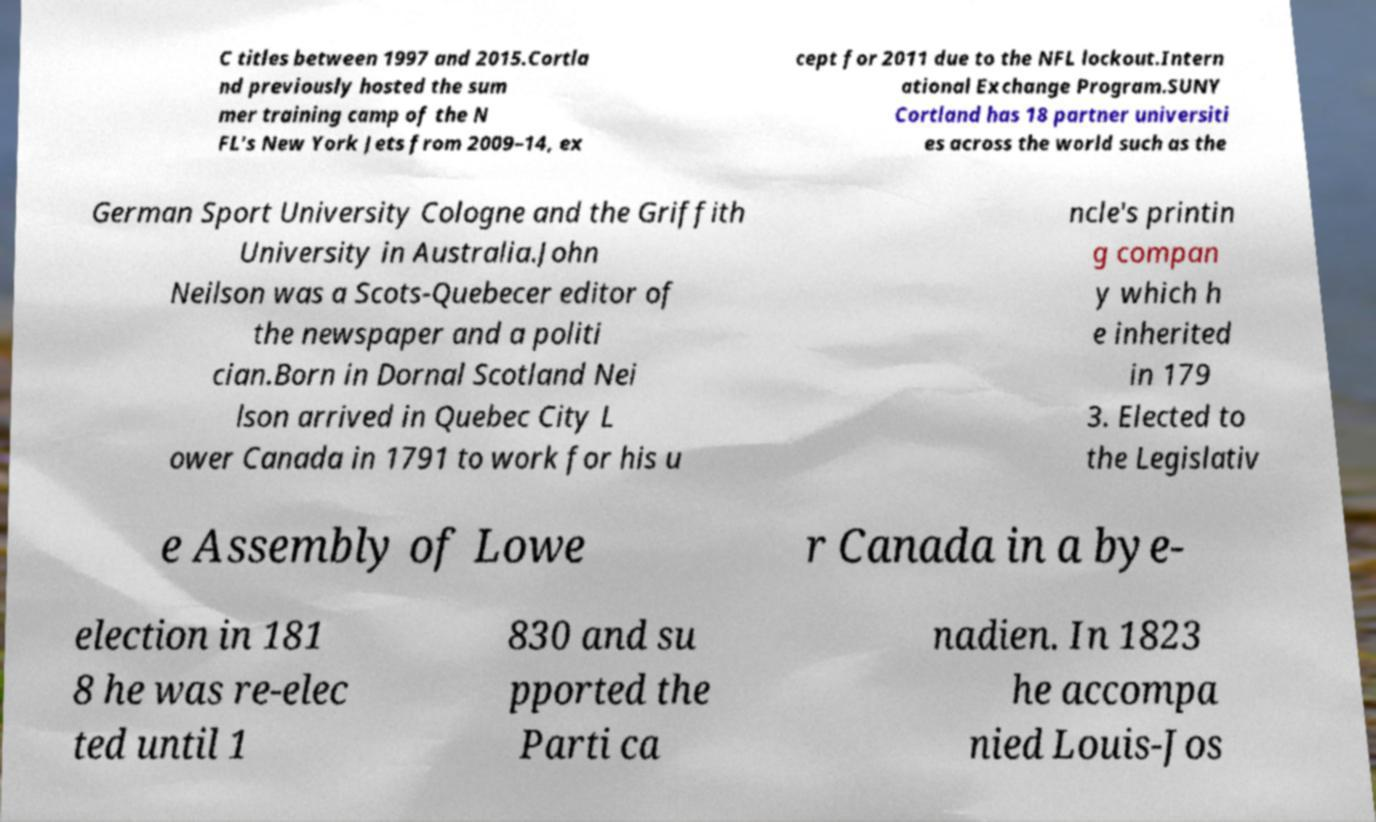I need the written content from this picture converted into text. Can you do that? C titles between 1997 and 2015.Cortla nd previously hosted the sum mer training camp of the N FL's New York Jets from 2009–14, ex cept for 2011 due to the NFL lockout.Intern ational Exchange Program.SUNY Cortland has 18 partner universiti es across the world such as the German Sport University Cologne and the Griffith University in Australia.John Neilson was a Scots-Quebecer editor of the newspaper and a politi cian.Born in Dornal Scotland Nei lson arrived in Quebec City L ower Canada in 1791 to work for his u ncle's printin g compan y which h e inherited in 179 3. Elected to the Legislativ e Assembly of Lowe r Canada in a bye- election in 181 8 he was re-elec ted until 1 830 and su pported the Parti ca nadien. In 1823 he accompa nied Louis-Jos 